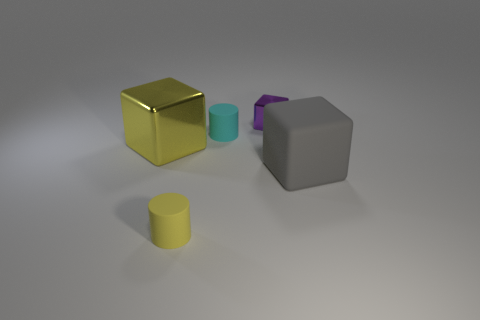The tiny matte cylinder that is in front of the gray rubber block is what color?
Offer a terse response. Yellow. How many gray objects are either tiny objects or tiny rubber things?
Your answer should be very brief. 0. What color is the big shiny cube?
Offer a terse response. Yellow. Are there any other things that are the same material as the small yellow object?
Your answer should be compact. Yes. Are there fewer cylinders that are left of the tiny cyan matte cylinder than small metallic objects in front of the big metallic thing?
Your answer should be very brief. No. The matte object that is both in front of the yellow cube and on the right side of the yellow cylinder has what shape?
Your answer should be very brief. Cube. What number of tiny things have the same shape as the large yellow object?
Your answer should be very brief. 1. The cube that is the same material as the tiny purple object is what size?
Make the answer very short. Large. What number of gray matte things have the same size as the purple metal thing?
Provide a succinct answer. 0. What size is the other object that is the same color as the big metal object?
Offer a very short reply. Small. 